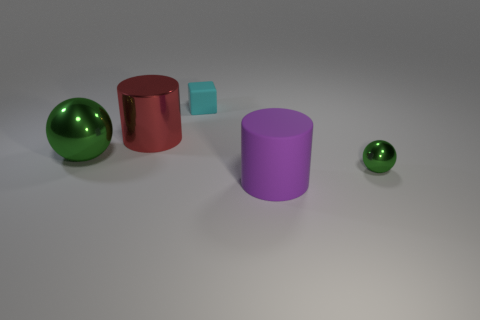Does the large matte object have the same color as the tiny shiny thing?
Your answer should be compact. No. What size is the green metal object that is behind the ball to the right of the purple cylinder?
Offer a terse response. Large. Are the large thing that is behind the large ball and the object left of the big red cylinder made of the same material?
Your answer should be compact. Yes. Does the tiny matte object behind the big metallic cylinder have the same color as the large ball?
Make the answer very short. No. What number of small shiny balls are in front of the purple object?
Make the answer very short. 0. Do the large purple cylinder and the large cylinder on the left side of the rubber cube have the same material?
Make the answer very short. No. There is a purple object that is made of the same material as the tiny cyan object; what is its size?
Your answer should be very brief. Large. Is the number of metal objects that are in front of the small sphere greater than the number of red shiny cylinders that are on the right side of the big red object?
Offer a terse response. No. Is there another large red metal thing of the same shape as the large red metal thing?
Provide a short and direct response. No. There is a rubber thing that is in front of the red metallic cylinder; does it have the same size as the tiny rubber thing?
Provide a short and direct response. No. 